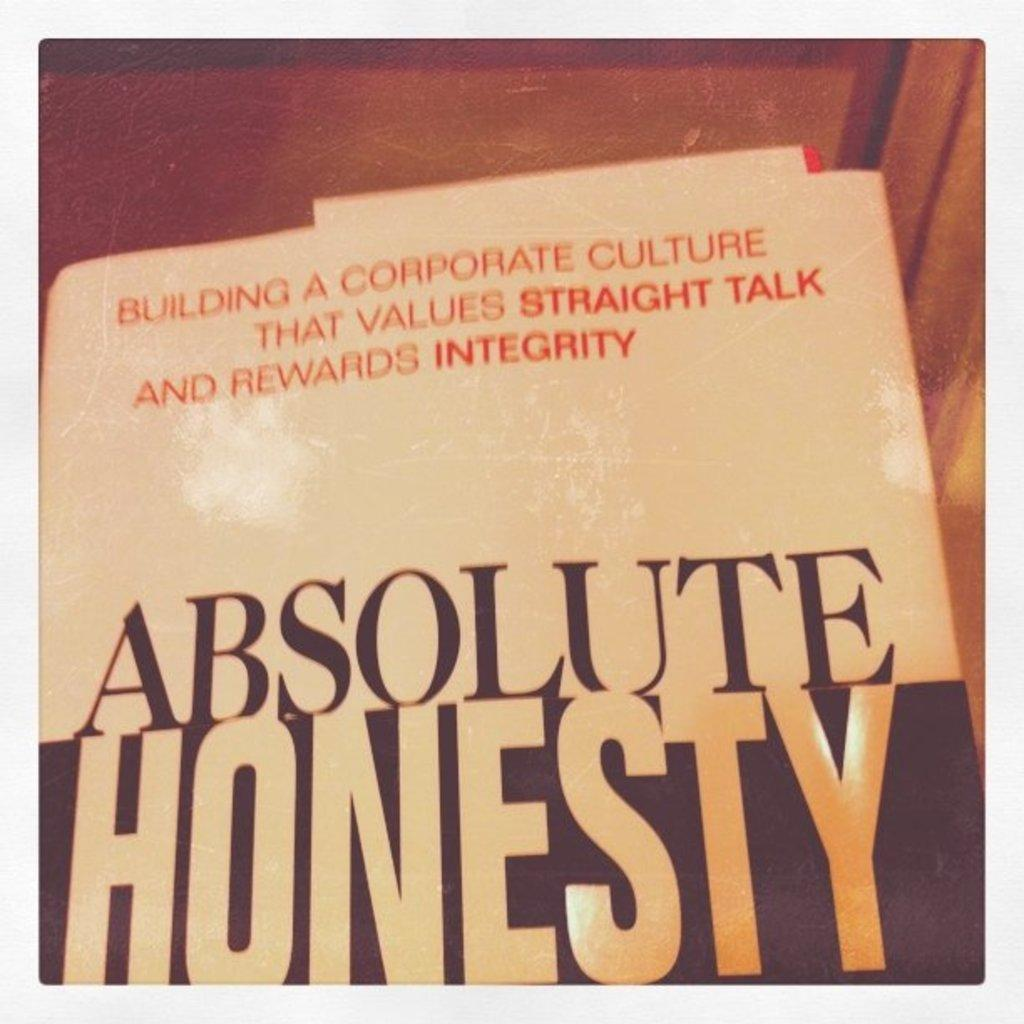<image>
Offer a succinct explanation of the picture presented. A book called Absolute Honesty is about building corporate culture. 